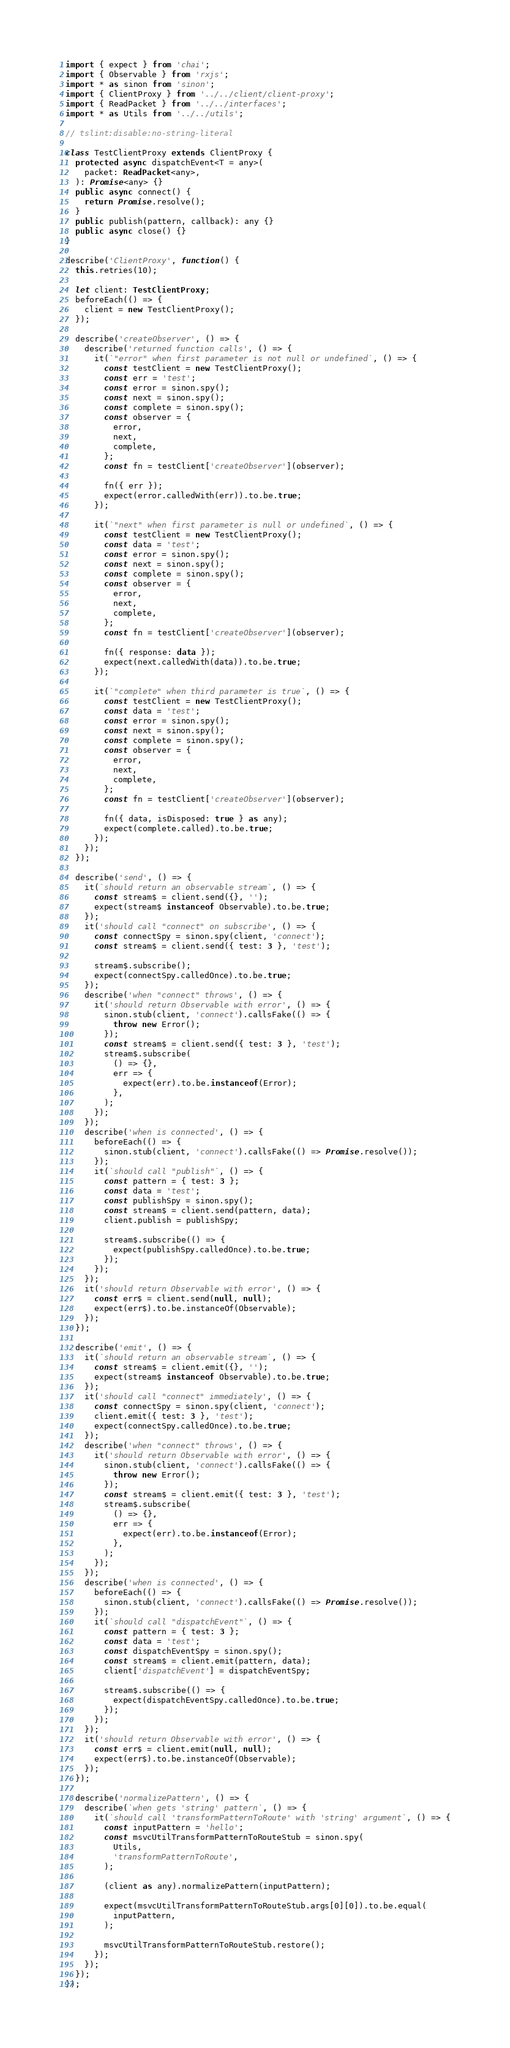<code> <loc_0><loc_0><loc_500><loc_500><_TypeScript_>import { expect } from 'chai';
import { Observable } from 'rxjs';
import * as sinon from 'sinon';
import { ClientProxy } from '../../client/client-proxy';
import { ReadPacket } from '../../interfaces';
import * as Utils from '../../utils';

// tslint:disable:no-string-literal

class TestClientProxy extends ClientProxy {
  protected async dispatchEvent<T = any>(
    packet: ReadPacket<any>,
  ): Promise<any> {}
  public async connect() {
    return Promise.resolve();
  }
  public publish(pattern, callback): any {}
  public async close() {}
}

describe('ClientProxy', function() {
  this.retries(10);

  let client: TestClientProxy;
  beforeEach(() => {
    client = new TestClientProxy();
  });

  describe('createObserver', () => {
    describe('returned function calls', () => {
      it(`"error" when first parameter is not null or undefined`, () => {
        const testClient = new TestClientProxy();
        const err = 'test';
        const error = sinon.spy();
        const next = sinon.spy();
        const complete = sinon.spy();
        const observer = {
          error,
          next,
          complete,
        };
        const fn = testClient['createObserver'](observer);

        fn({ err });
        expect(error.calledWith(err)).to.be.true;
      });

      it(`"next" when first parameter is null or undefined`, () => {
        const testClient = new TestClientProxy();
        const data = 'test';
        const error = sinon.spy();
        const next = sinon.spy();
        const complete = sinon.spy();
        const observer = {
          error,
          next,
          complete,
        };
        const fn = testClient['createObserver'](observer);

        fn({ response: data });
        expect(next.calledWith(data)).to.be.true;
      });

      it(`"complete" when third parameter is true`, () => {
        const testClient = new TestClientProxy();
        const data = 'test';
        const error = sinon.spy();
        const next = sinon.spy();
        const complete = sinon.spy();
        const observer = {
          error,
          next,
          complete,
        };
        const fn = testClient['createObserver'](observer);

        fn({ data, isDisposed: true } as any);
        expect(complete.called).to.be.true;
      });
    });
  });

  describe('send', () => {
    it(`should return an observable stream`, () => {
      const stream$ = client.send({}, '');
      expect(stream$ instanceof Observable).to.be.true;
    });
    it('should call "connect" on subscribe', () => {
      const connectSpy = sinon.spy(client, 'connect');
      const stream$ = client.send({ test: 3 }, 'test');

      stream$.subscribe();
      expect(connectSpy.calledOnce).to.be.true;
    });
    describe('when "connect" throws', () => {
      it('should return Observable with error', () => {
        sinon.stub(client, 'connect').callsFake(() => {
          throw new Error();
        });
        const stream$ = client.send({ test: 3 }, 'test');
        stream$.subscribe(
          () => {},
          err => {
            expect(err).to.be.instanceof(Error);
          },
        );
      });
    });
    describe('when is connected', () => {
      beforeEach(() => {
        sinon.stub(client, 'connect').callsFake(() => Promise.resolve());
      });
      it(`should call "publish"`, () => {
        const pattern = { test: 3 };
        const data = 'test';
        const publishSpy = sinon.spy();
        const stream$ = client.send(pattern, data);
        client.publish = publishSpy;

        stream$.subscribe(() => {
          expect(publishSpy.calledOnce).to.be.true;
        });
      });
    });
    it('should return Observable with error', () => {
      const err$ = client.send(null, null);
      expect(err$).to.be.instanceOf(Observable);
    });
  });

  describe('emit', () => {
    it(`should return an observable stream`, () => {
      const stream$ = client.emit({}, '');
      expect(stream$ instanceof Observable).to.be.true;
    });
    it('should call "connect" immediately', () => {
      const connectSpy = sinon.spy(client, 'connect');
      client.emit({ test: 3 }, 'test');
      expect(connectSpy.calledOnce).to.be.true;
    });
    describe('when "connect" throws', () => {
      it('should return Observable with error', () => {
        sinon.stub(client, 'connect').callsFake(() => {
          throw new Error();
        });
        const stream$ = client.emit({ test: 3 }, 'test');
        stream$.subscribe(
          () => {},
          err => {
            expect(err).to.be.instanceof(Error);
          },
        );
      });
    });
    describe('when is connected', () => {
      beforeEach(() => {
        sinon.stub(client, 'connect').callsFake(() => Promise.resolve());
      });
      it(`should call "dispatchEvent"`, () => {
        const pattern = { test: 3 };
        const data = 'test';
        const dispatchEventSpy = sinon.spy();
        const stream$ = client.emit(pattern, data);
        client['dispatchEvent'] = dispatchEventSpy;

        stream$.subscribe(() => {
          expect(dispatchEventSpy.calledOnce).to.be.true;
        });
      });
    });
    it('should return Observable with error', () => {
      const err$ = client.emit(null, null);
      expect(err$).to.be.instanceOf(Observable);
    });
  });

  describe('normalizePattern', () => {
    describe(`when gets 'string' pattern`, () => {
      it(`should call 'transformPatternToRoute' with 'string' argument`, () => {
        const inputPattern = 'hello';
        const msvcUtilTransformPatternToRouteStub = sinon.spy(
          Utils,
          'transformPatternToRoute',
        );

        (client as any).normalizePattern(inputPattern);

        expect(msvcUtilTransformPatternToRouteStub.args[0][0]).to.be.equal(
          inputPattern,
        );

        msvcUtilTransformPatternToRouteStub.restore();
      });
    });
  });
});
</code> 